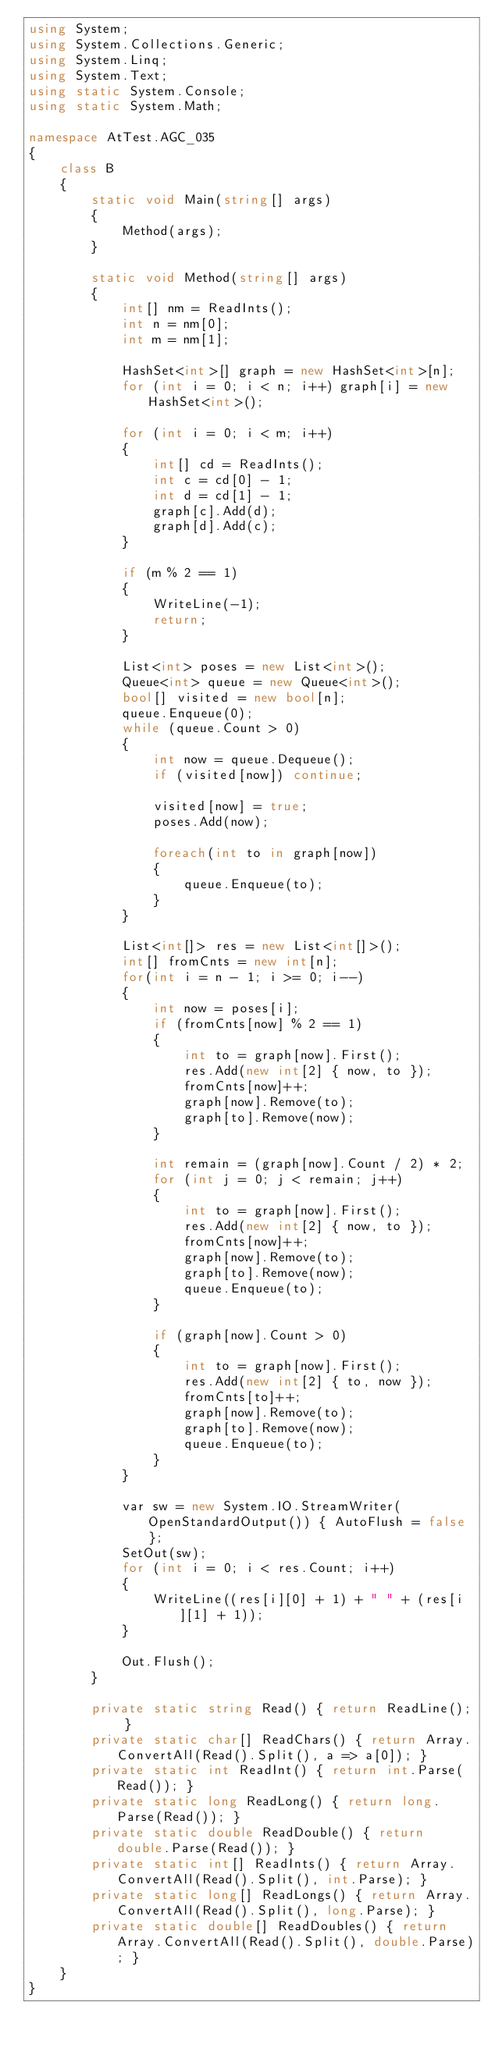Convert code to text. <code><loc_0><loc_0><loc_500><loc_500><_C#_>using System;
using System.Collections.Generic;
using System.Linq;
using System.Text;
using static System.Console;
using static System.Math;

namespace AtTest.AGC_035
{
    class B
    {
        static void Main(string[] args)
        {
            Method(args);
        }

        static void Method(string[] args)
        {
            int[] nm = ReadInts();
            int n = nm[0];
            int m = nm[1];

            HashSet<int>[] graph = new HashSet<int>[n];
            for (int i = 0; i < n; i++) graph[i] = new HashSet<int>();

            for (int i = 0; i < m; i++)
            {
                int[] cd = ReadInts();
                int c = cd[0] - 1;
                int d = cd[1] - 1;
                graph[c].Add(d);
                graph[d].Add(c);
            }

            if (m % 2 == 1)
            {
                WriteLine(-1);
                return;
            }

            List<int> poses = new List<int>();
            Queue<int> queue = new Queue<int>();
            bool[] visited = new bool[n];
            queue.Enqueue(0);
            while (queue.Count > 0)
            {
                int now = queue.Dequeue();
                if (visited[now]) continue;

                visited[now] = true;
                poses.Add(now);

                foreach(int to in graph[now])
                {
                    queue.Enqueue(to);
                }
            }

            List<int[]> res = new List<int[]>();
            int[] fromCnts = new int[n];
            for(int i = n - 1; i >= 0; i--)
            {
                int now = poses[i];
                if (fromCnts[now] % 2 == 1)
                {
                    int to = graph[now].First();
                    res.Add(new int[2] { now, to });
                    fromCnts[now]++;
                    graph[now].Remove(to);
                    graph[to].Remove(now);
                }

                int remain = (graph[now].Count / 2) * 2;
                for (int j = 0; j < remain; j++)
                {
                    int to = graph[now].First();
                    res.Add(new int[2] { now, to });
                    fromCnts[now]++;
                    graph[now].Remove(to);
                    graph[to].Remove(now);
                    queue.Enqueue(to);
                }

                if (graph[now].Count > 0)
                {
                    int to = graph[now].First();
                    res.Add(new int[2] { to, now });
                    fromCnts[to]++;
                    graph[now].Remove(to);
                    graph[to].Remove(now);
                    queue.Enqueue(to);
                }
            }

            var sw = new System.IO.StreamWriter(OpenStandardOutput()) { AutoFlush = false };
            SetOut(sw);
            for (int i = 0; i < res.Count; i++)
            {
                WriteLine((res[i][0] + 1) + " " + (res[i][1] + 1));
            }

            Out.Flush();
        }

        private static string Read() { return ReadLine(); }
        private static char[] ReadChars() { return Array.ConvertAll(Read().Split(), a => a[0]); }
        private static int ReadInt() { return int.Parse(Read()); }
        private static long ReadLong() { return long.Parse(Read()); }
        private static double ReadDouble() { return double.Parse(Read()); }
        private static int[] ReadInts() { return Array.ConvertAll(Read().Split(), int.Parse); }
        private static long[] ReadLongs() { return Array.ConvertAll(Read().Split(), long.Parse); }
        private static double[] ReadDoubles() { return Array.ConvertAll(Read().Split(), double.Parse); }
    }
}
</code> 